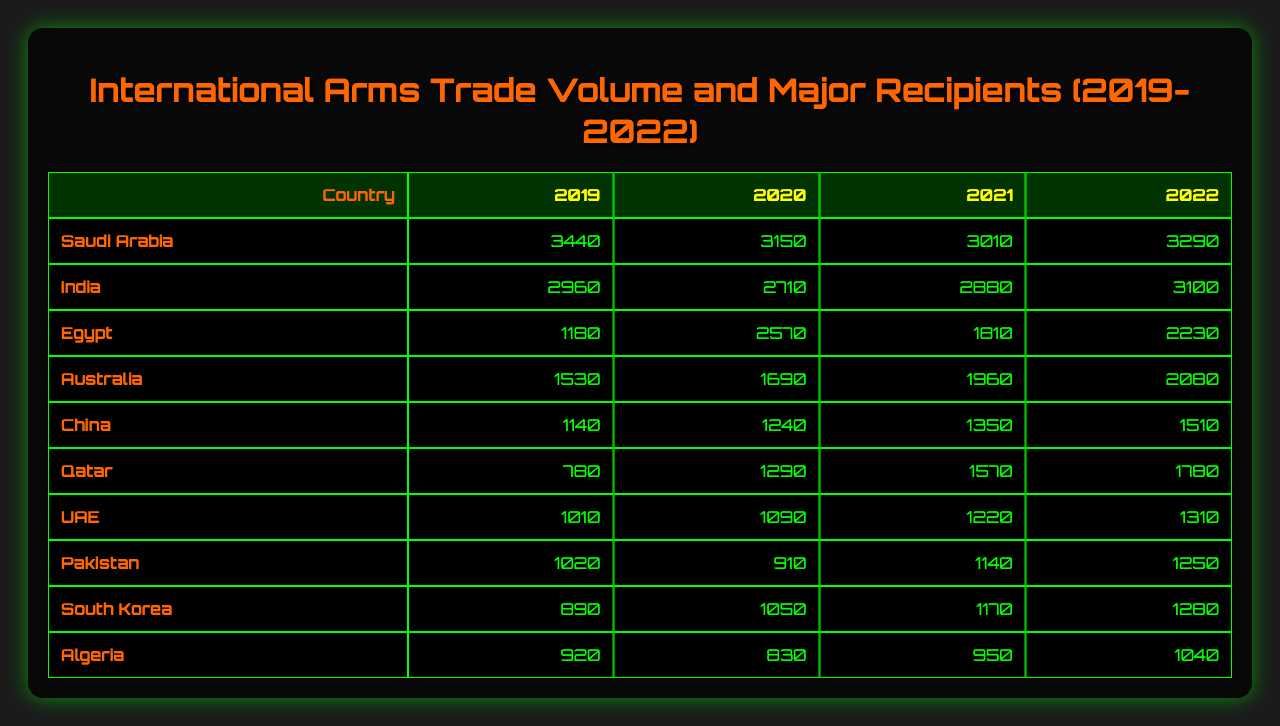What was the arms trade volume for India in 2022? India’s arms trade volume for 2022 is directly obtained from the table, which indicates it to be 3100.
Answer: 3100 Which country had the highest arms trade volume in 2020? By observing the values in the 2020 column for each country, Saudi Arabia has the highest volume with 3150.
Answer: Saudi Arabia What is the total arms trade volume of Egypt from 2019 to 2022? The volumes for Egypt are 1180 (2019), 2570 (2020), 1810 (2021), and 2230 (2022). Adding these gives 1180 + 2570 + 1810 + 2230 = 7790.
Answer: 7790 Did the arms trade volume for Qatar increase every year from 2019 to 2022? Checking the annual data reveals that Qatar had 780 in 2019, increased to 1290 in 2020, then to 1570 in 2021, and further to 1780 in 2022, indicating a consistent increase.
Answer: Yes What was the average arms trade volume for Australia over the four years? The values for Australia are 1530, 1690, 1960, and 2080. Summing these gives 1530 + 1690 + 1960 + 2080 = 9260. The average is 9260 divided by 4, equals 2315.
Answer: 2315 How much more did Saudi Arabia trade in arms in 2022 compared to 2019? The arms trade volumes for Saudi Arabia are 3440 in 2019 and 3290 in 2022. The difference is 3290 - 3440 = -150, which means it decreased.
Answer: Decreased by 150 Which country had the lowest arms trade volume in 2021? Looking at the 2021 column, the smallest value is for Pakistan at 1140.
Answer: Pakistan What is the total arms trade volume of the top three recipients in 2021? The top three recipients in 2021 are Saudi Arabia (3010), India (2880), and Egypt (1810). Their total is 3010 + 2880 + 1810 = 7700.
Answer: 7700 Was the total arms trade volume for all countries higher in 2022 compared to 2021? To assess this, the totals for both years must be calculated. For 2022: 3290 + 3100 + 2230 + 2080 + 1510 + 1780 + 1310 + 1250 + 1280 + 1040 = 19070, and for 2021: 3010 + 2880 + 1810 + 1960 + 1350 + 1570 + 1220 + 1140 + 1170 + 950 = 19570. Since 19070 is less than 19570, the answer is no.
Answer: No Which country showed the least variation in arms trade volume across the four years? Variation can be assessed by looking at the differences in yearly volumes for each country. A comparison reveals that China has values of 1140 (2019), 1240 (2020), 1350 (2021), and 1510 (2022), seeing a gradual increase. The change is less pronounced compared to others.
Answer: China 